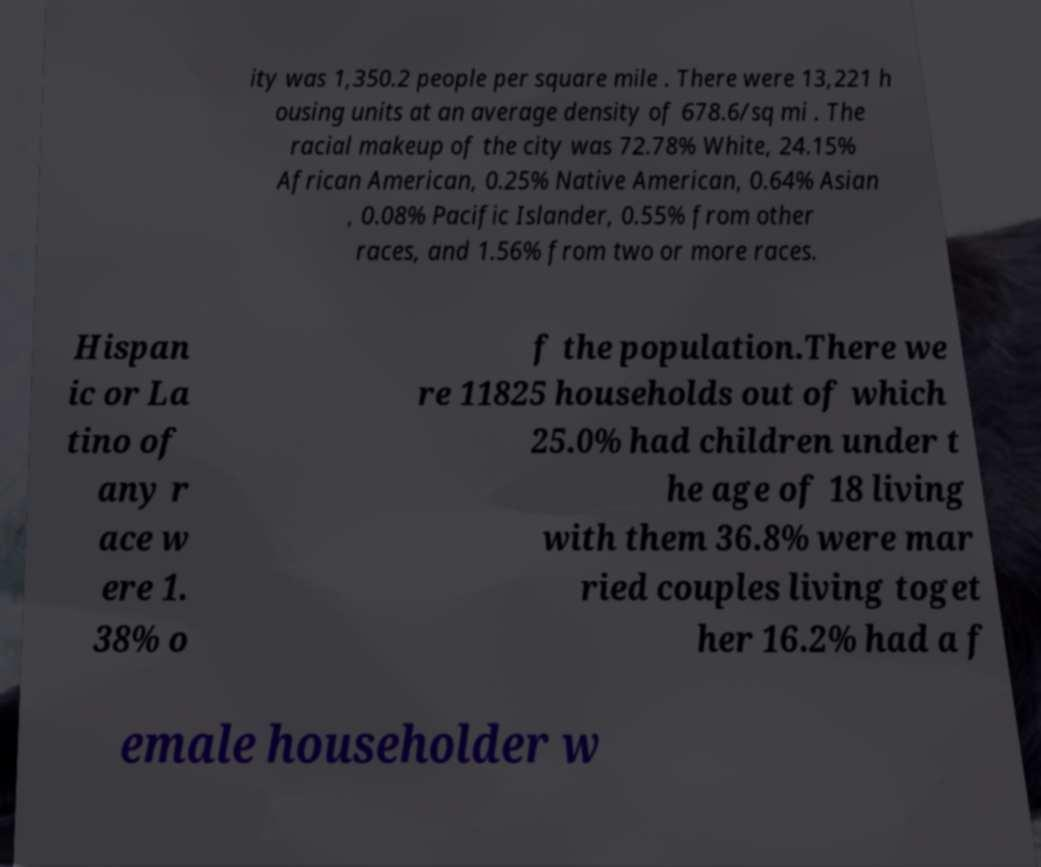For documentation purposes, I need the text within this image transcribed. Could you provide that? ity was 1,350.2 people per square mile . There were 13,221 h ousing units at an average density of 678.6/sq mi . The racial makeup of the city was 72.78% White, 24.15% African American, 0.25% Native American, 0.64% Asian , 0.08% Pacific Islander, 0.55% from other races, and 1.56% from two or more races. Hispan ic or La tino of any r ace w ere 1. 38% o f the population.There we re 11825 households out of which 25.0% had children under t he age of 18 living with them 36.8% were mar ried couples living toget her 16.2% had a f emale householder w 